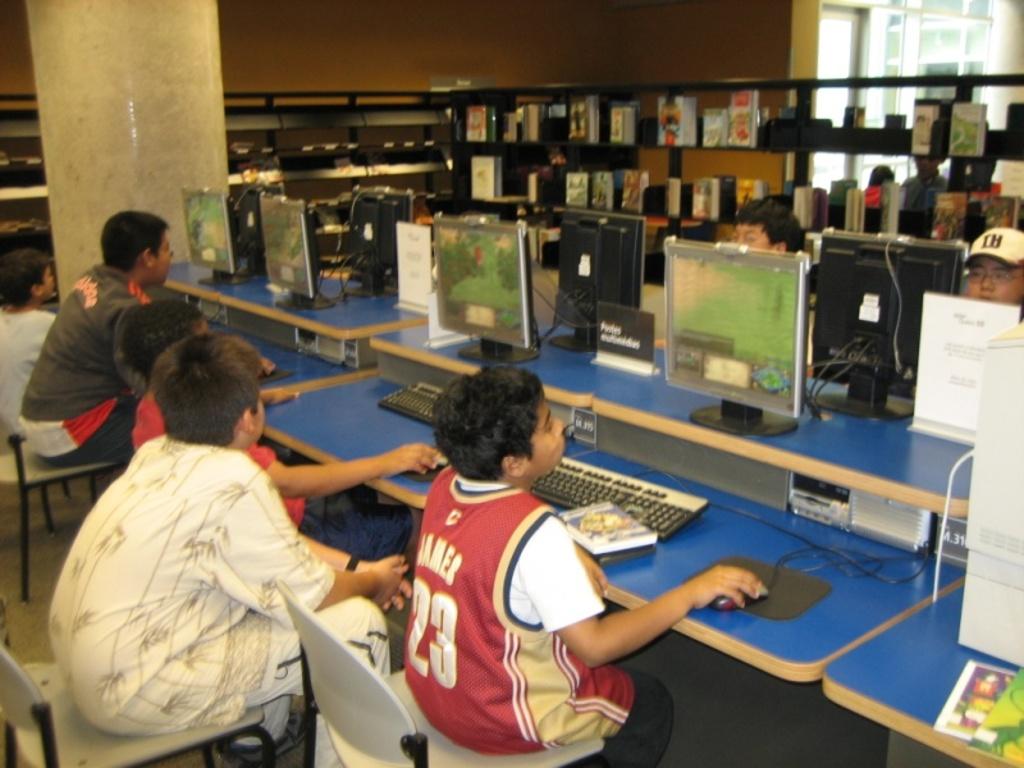What is the number on the boys sports jersey?
Your answer should be very brief. 23. 